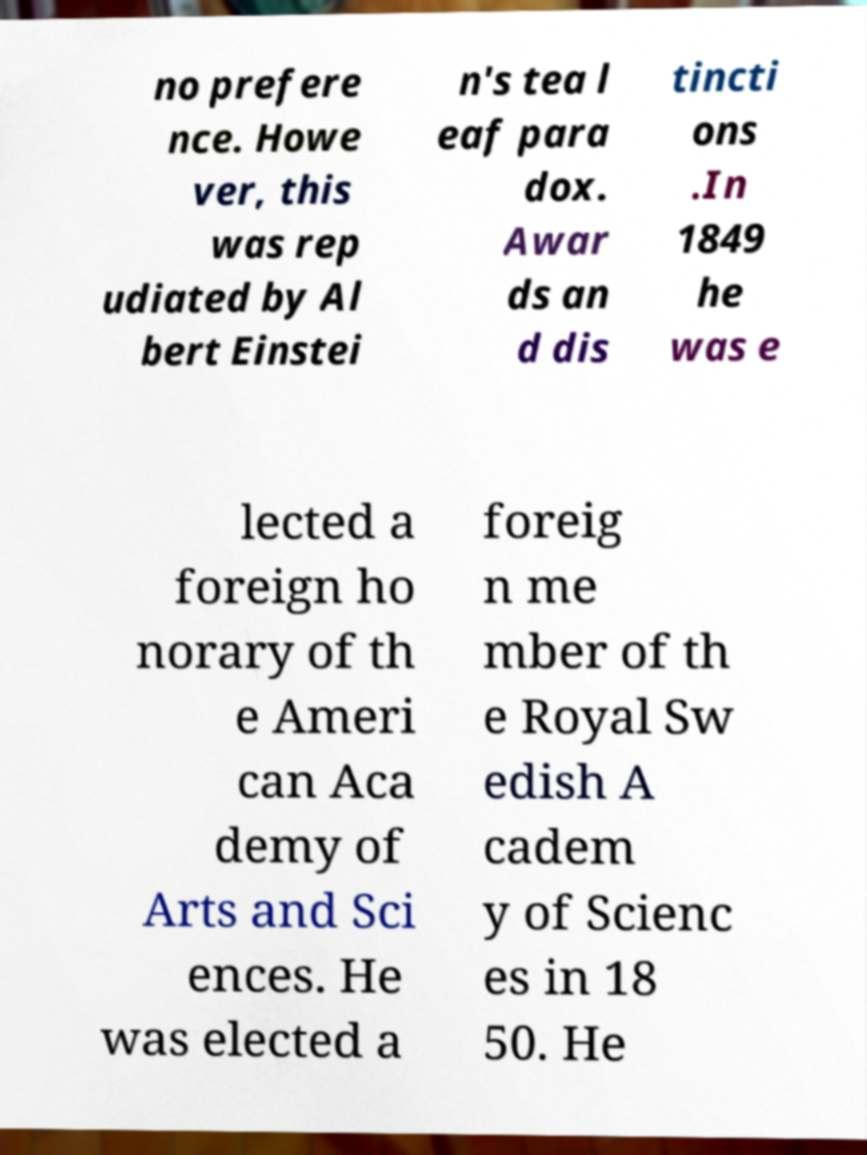What messages or text are displayed in this image? I need them in a readable, typed format. no prefere nce. Howe ver, this was rep udiated by Al bert Einstei n's tea l eaf para dox. Awar ds an d dis tincti ons .In 1849 he was e lected a foreign ho norary of th e Ameri can Aca demy of Arts and Sci ences. He was elected a foreig n me mber of th e Royal Sw edish A cadem y of Scienc es in 18 50. He 